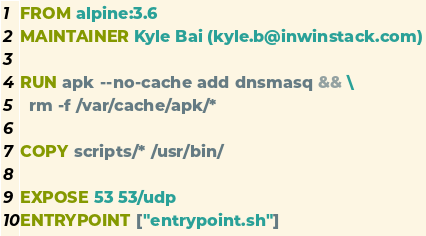Convert code to text. <code><loc_0><loc_0><loc_500><loc_500><_Dockerfile_>FROM alpine:3.6
MAINTAINER Kyle Bai (kyle.b@inwinstack.com)

RUN apk --no-cache add dnsmasq && \
  rm -f /var/cache/apk/*

COPY scripts/* /usr/bin/

EXPOSE 53 53/udp
ENTRYPOINT ["entrypoint.sh"]
</code> 